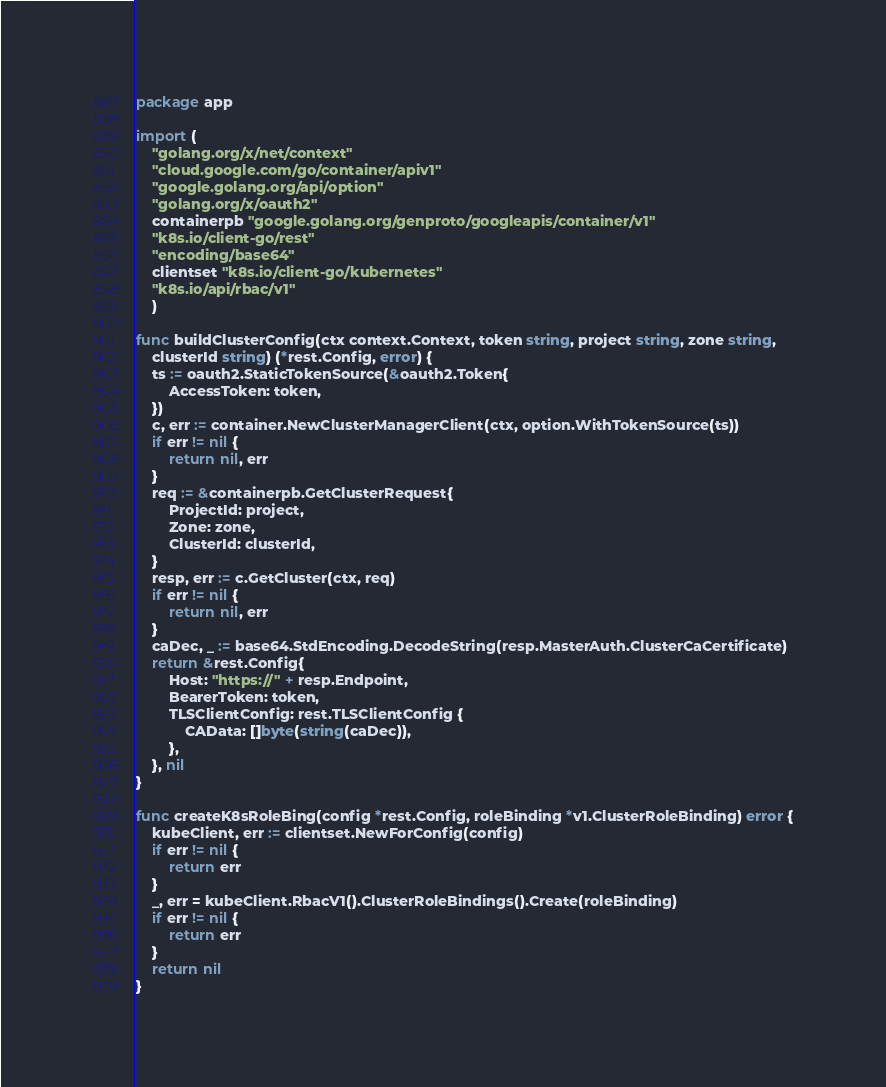Convert code to text. <code><loc_0><loc_0><loc_500><loc_500><_Go_>package app

import (
	"golang.org/x/net/context"
	"cloud.google.com/go/container/apiv1"
	"google.golang.org/api/option"
	"golang.org/x/oauth2"
	containerpb "google.golang.org/genproto/googleapis/container/v1"
	"k8s.io/client-go/rest"
	"encoding/base64"
	clientset "k8s.io/client-go/kubernetes"
	"k8s.io/api/rbac/v1"
	)

func buildClusterConfig(ctx context.Context, token string, project string, zone string,
	clusterId string) (*rest.Config, error) {
	ts := oauth2.StaticTokenSource(&oauth2.Token{
		AccessToken: token,
	})
	c, err := container.NewClusterManagerClient(ctx, option.WithTokenSource(ts))
	if err != nil {
		return nil, err
	}
	req := &containerpb.GetClusterRequest{
		ProjectId: project,
		Zone: zone,
		ClusterId: clusterId,
	}
	resp, err := c.GetCluster(ctx, req)
	if err != nil {
		return nil, err
	}
	caDec, _ := base64.StdEncoding.DecodeString(resp.MasterAuth.ClusterCaCertificate)
	return &rest.Config{
		Host: "https://" + resp.Endpoint,
		BearerToken: token,
		TLSClientConfig: rest.TLSClientConfig {
			CAData: []byte(string(caDec)),
		},
	}, nil
}

func createK8sRoleBing(config *rest.Config, roleBinding *v1.ClusterRoleBinding) error {
	kubeClient, err := clientset.NewForConfig(config)
	if err != nil {
		return err
	}
	_, err = kubeClient.RbacV1().ClusterRoleBindings().Create(roleBinding)
	if err != nil {
		return err
	}
	return nil
}
</code> 